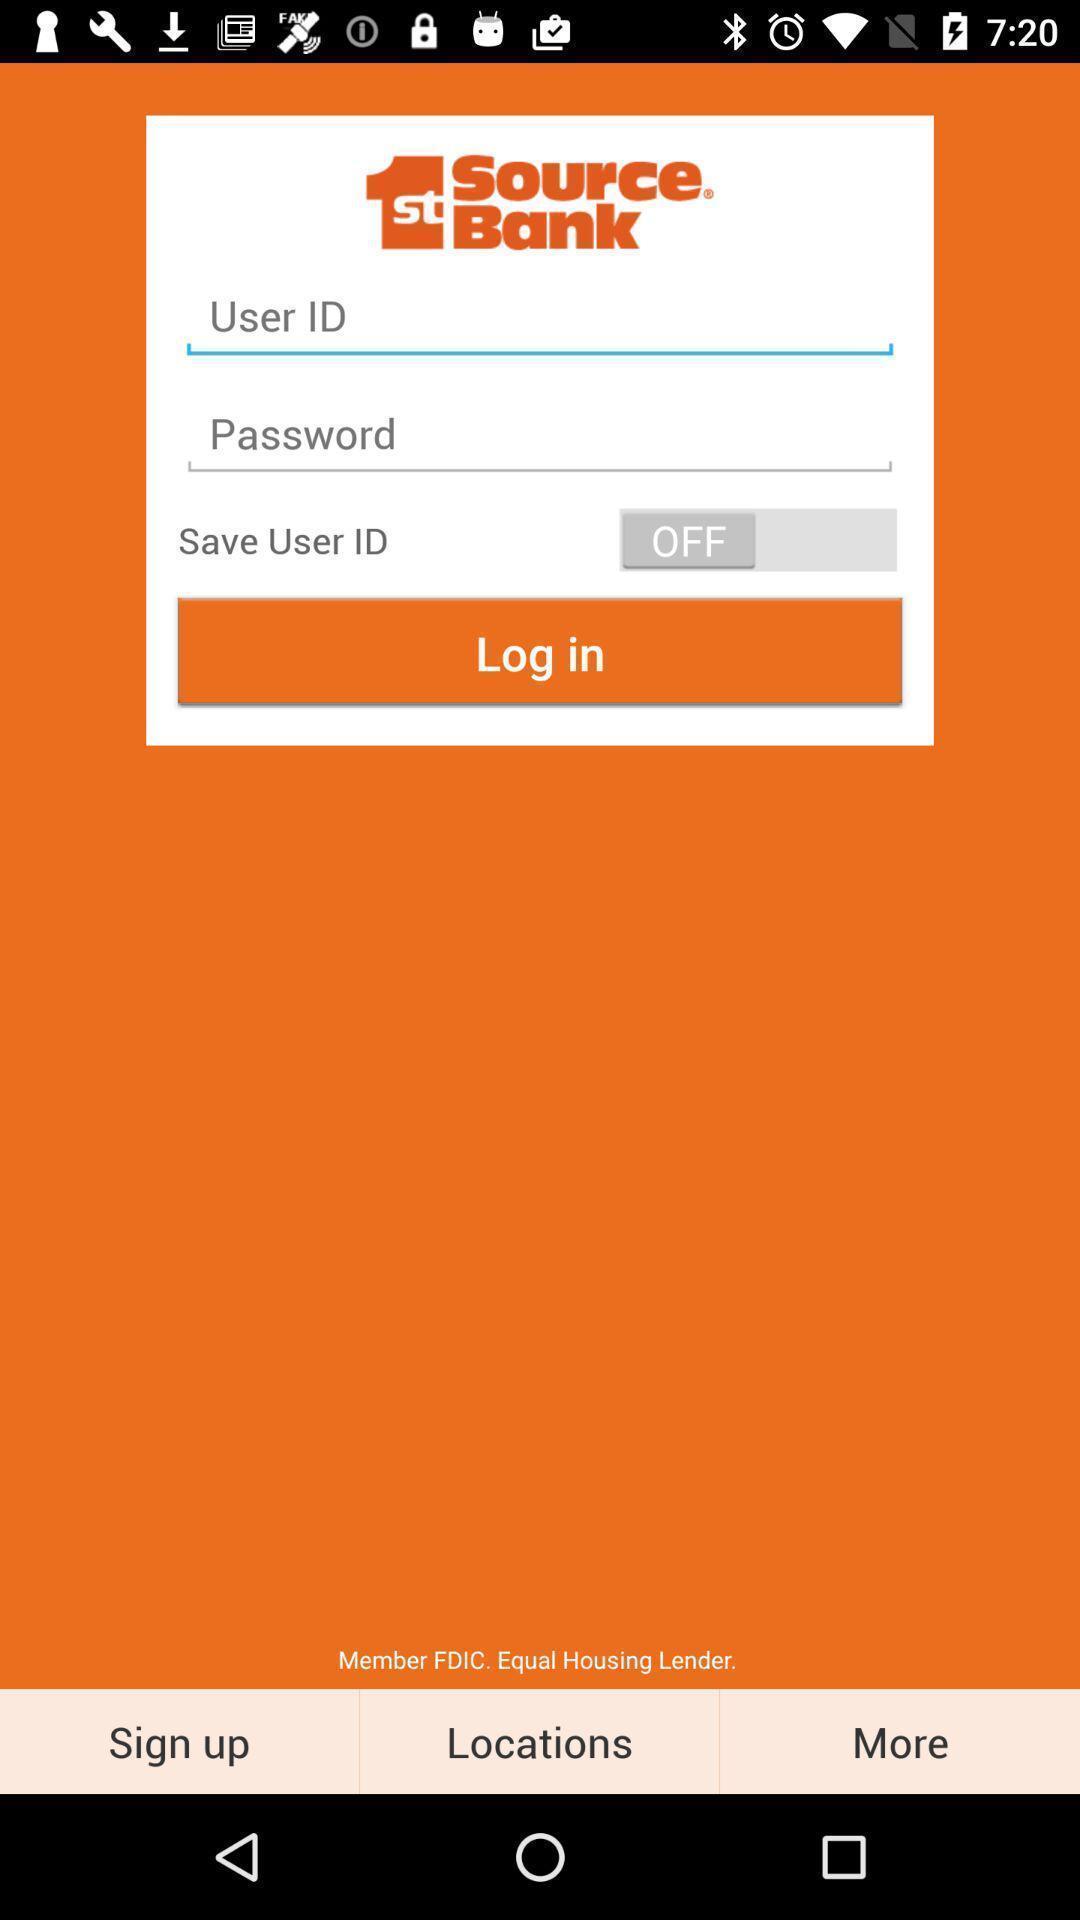Describe the visual elements of this screenshot. Page displaying signing in information about a banking application. 